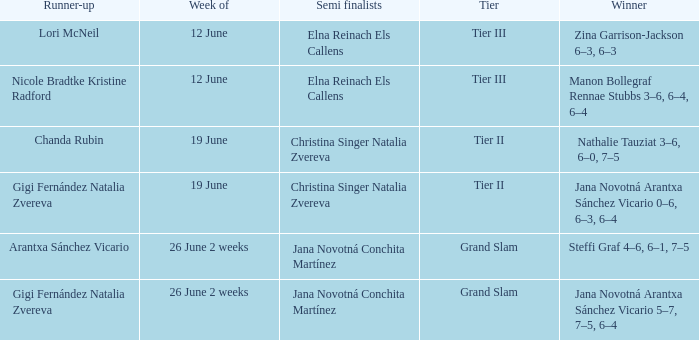When the Tier is listed as tier iii, who is the Winner? Zina Garrison-Jackson 6–3, 6–3, Manon Bollegraf Rennae Stubbs 3–6, 6–4, 6–4. 